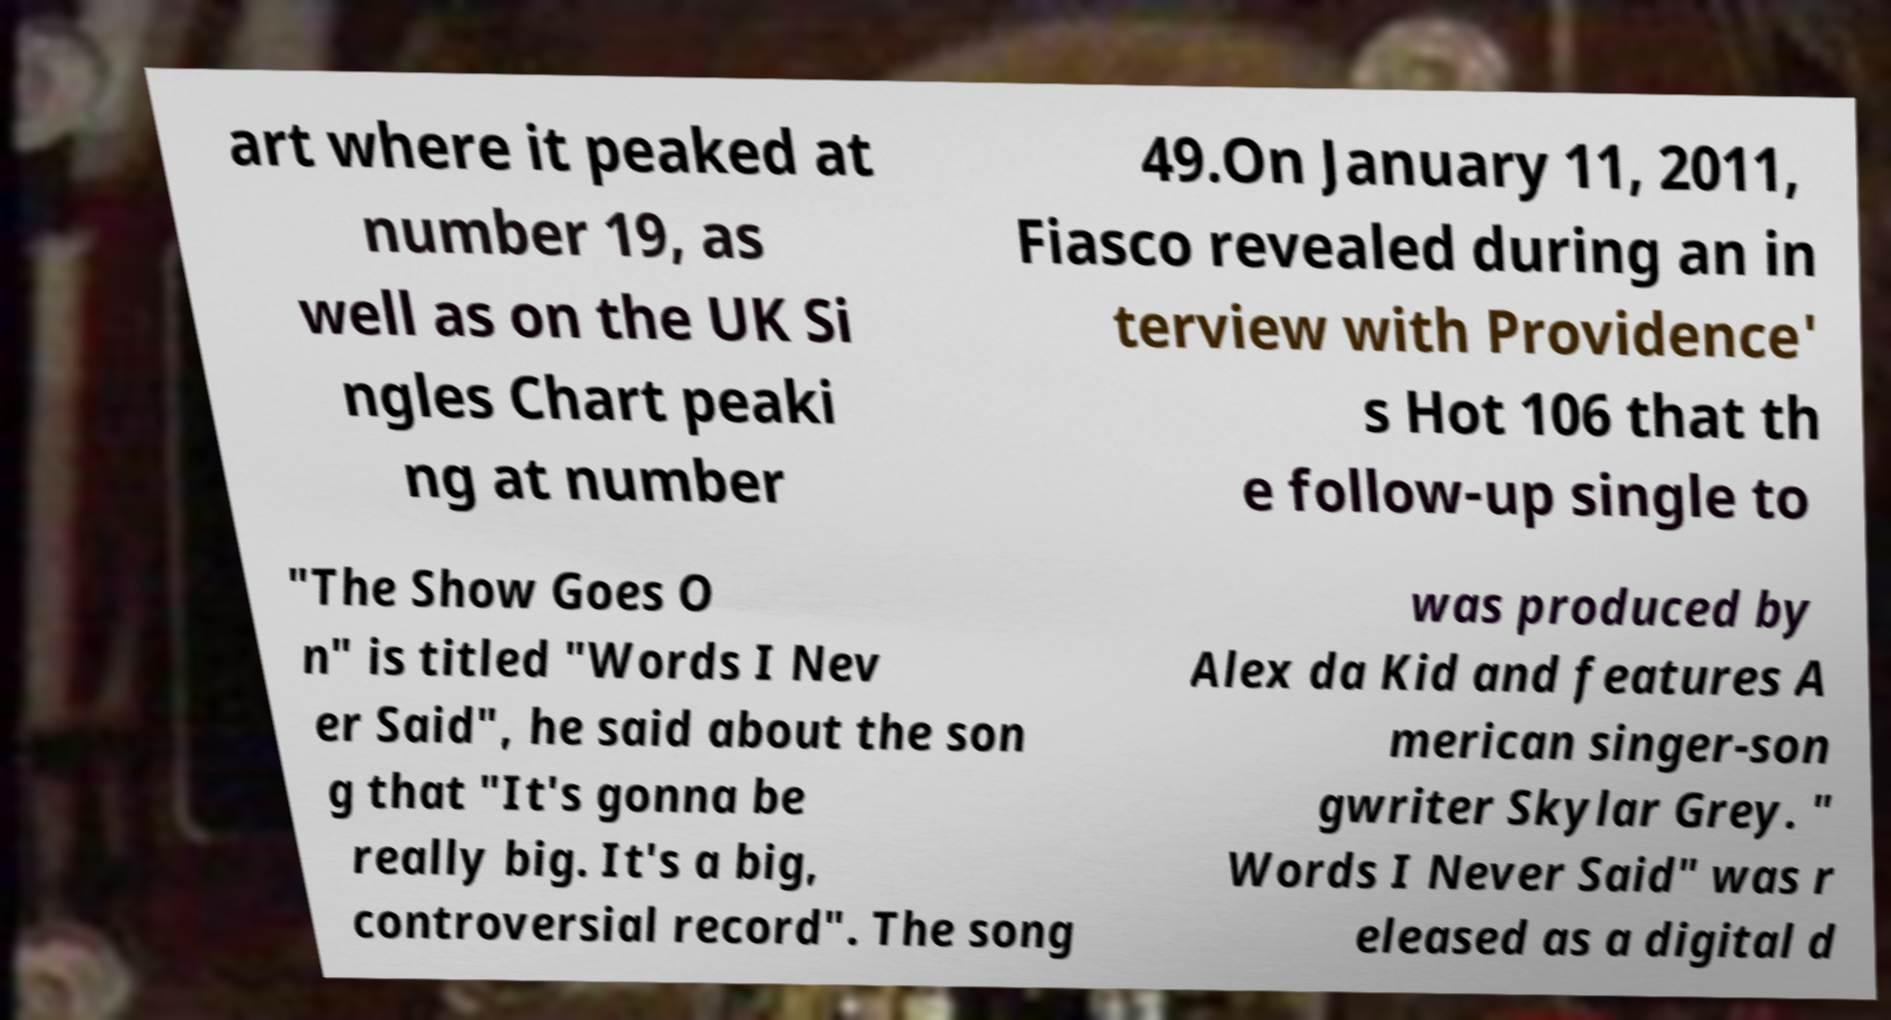Could you assist in decoding the text presented in this image and type it out clearly? art where it peaked at number 19, as well as on the UK Si ngles Chart peaki ng at number 49.On January 11, 2011, Fiasco revealed during an in terview with Providence' s Hot 106 that th e follow-up single to "The Show Goes O n" is titled "Words I Nev er Said", he said about the son g that "It's gonna be really big. It's a big, controversial record". The song was produced by Alex da Kid and features A merican singer-son gwriter Skylar Grey. " Words I Never Said" was r eleased as a digital d 